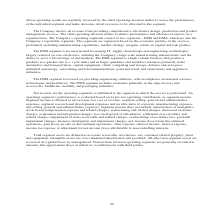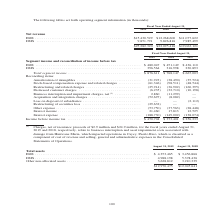According to Jabil Circuit's financial document, How are total segment assets defined? accounts receivable, inventories, net, customer-related property, plant and equipment, intangible assets net of accumulated amortization and goodwill.. The document states: "Total segment assets are defined as accounts receivable, inventories, net, customer-related property, plant and equipment, intangible assets net of ac..." Also, What was the amount of Other non-allocated assets in 2019?  According to the financial document, 3,628,812 (in thousands). The relevant text states: "4,988,198 5,378,436 Other non-allocated assets . 3,628,812 3,210,339..." Also, What was the amount of EMS Assets in 2019? According to the financial document, $4,353,465 (in thousands). The relevant text states: "Total assets EMS . $ 4,353,465 $ 3,456,866 DMS . 4,988,198 5,378,436 Other non-allocated assets . 3,628,812 3,210,339..." Also, How many assets in 2019 exceeded $4,000,000 thousand? Counting the relevant items in the document: EMS, DMS, I find 2 instances. The key data points involved are: DMS, EMS. Also, can you calculate: What was the change in total DMS assets between 2018 and 2019? Based on the calculation: 4,988,198-5,378,436, the result is -390238 (in thousands). This is based on the information: "Total assets EMS . $ 4,353,465 $ 3,456,866 DMS . 4,988,198 5,378,436 Other non-allocated assets . 3,628,812 3,210,339 ets EMS . $ 4,353,465 $ 3,456,866 DMS . 4,988,198 5,378,436 Other non-allocated as..." The key data points involved are: 4,988,198, 5,378,436. Also, can you calculate: What was the percentage change in total assets between 2018 and 2019? To answer this question, I need to perform calculations using the financial data. The calculation is: ($12,970,475-$12,045,641)/$12,045,641, which equals 7.68 (percentage). This is based on the information: "$12,970,475 $12,045,641 $12,970,475 $12,045,641..." The key data points involved are: 12,045,641, 12,970,475. 